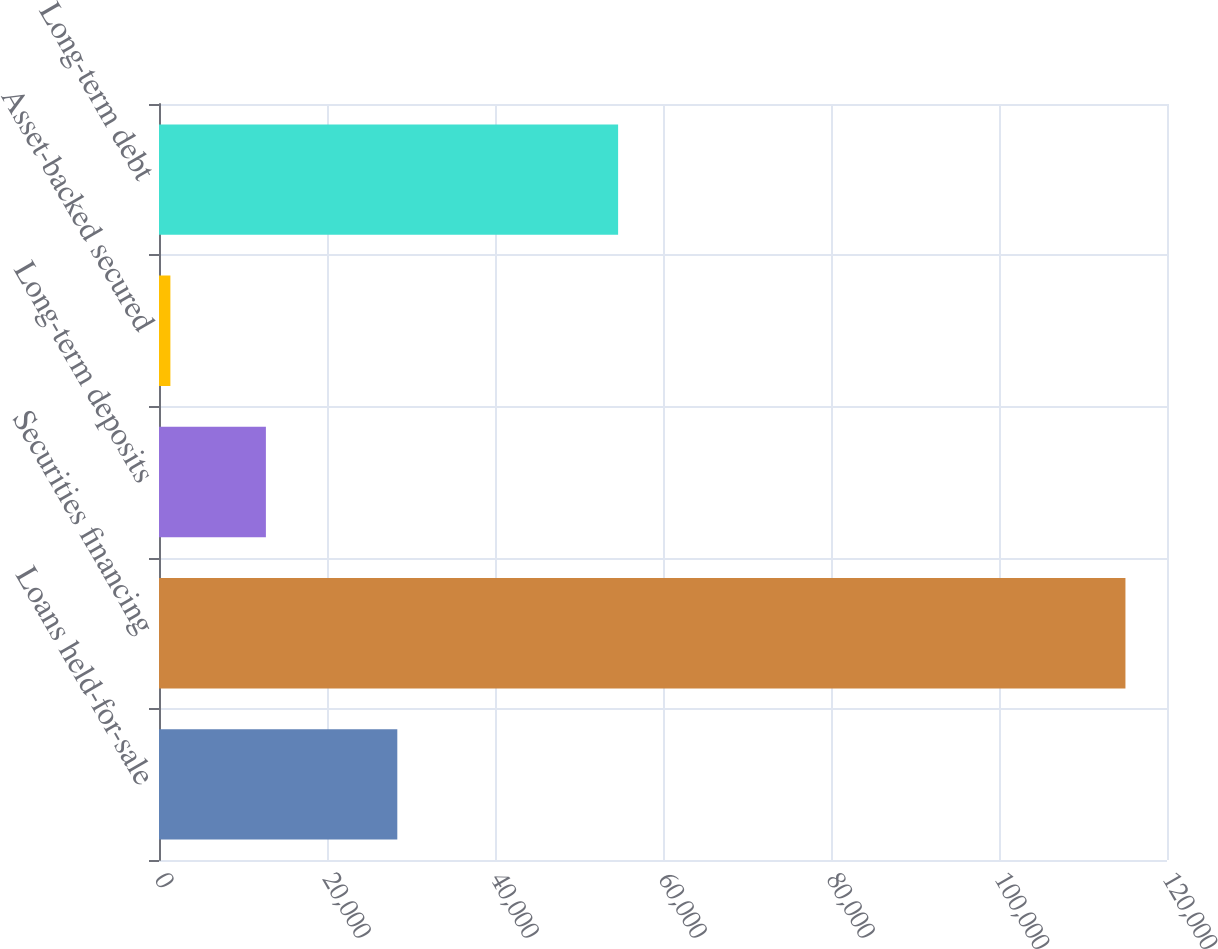<chart> <loc_0><loc_0><loc_500><loc_500><bar_chart><fcel>Loans held-for-sale<fcel>Securities financing<fcel>Long-term deposits<fcel>Asset-backed secured<fcel>Long-term debt<nl><fcel>28370<fcel>115053<fcel>12725.7<fcel>1356<fcel>54656<nl></chart> 